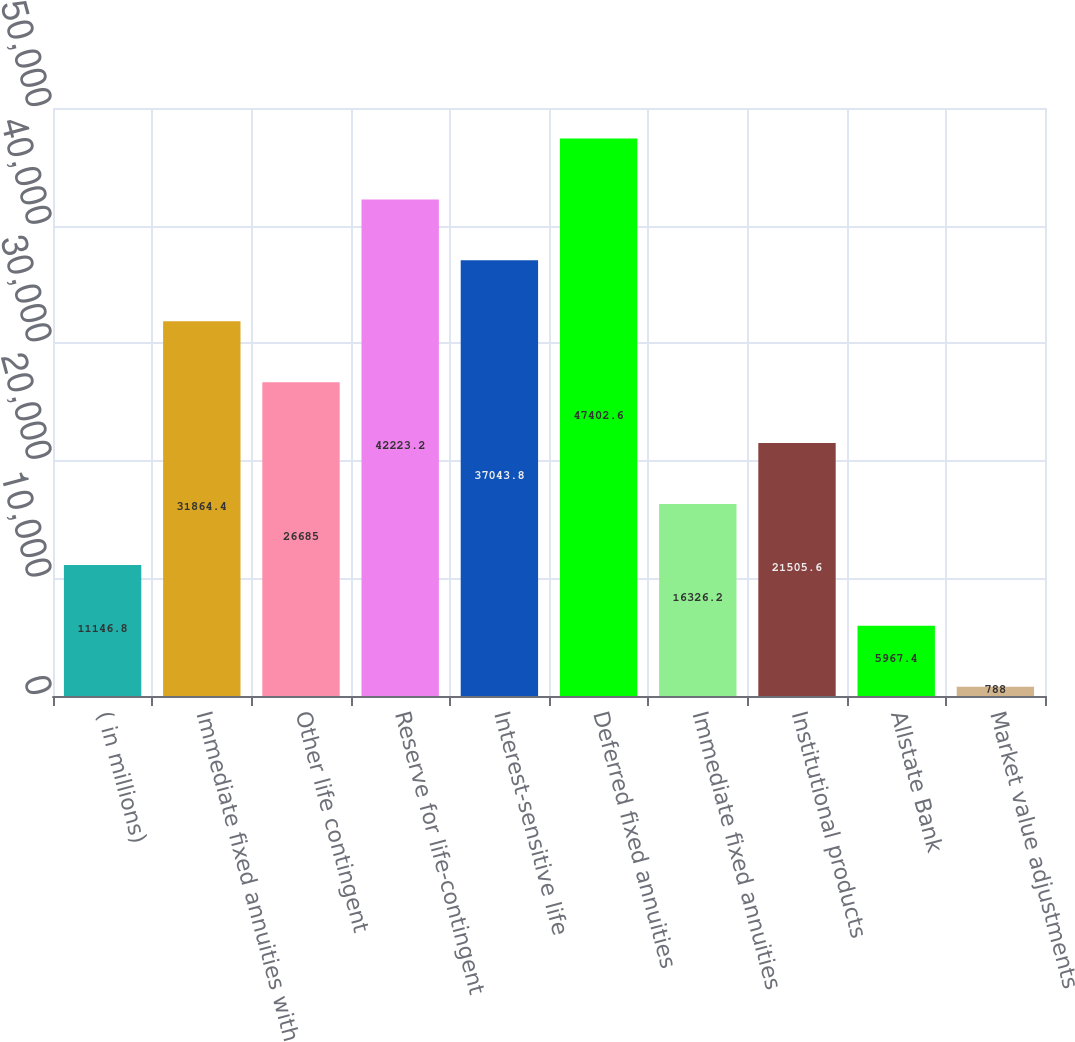<chart> <loc_0><loc_0><loc_500><loc_500><bar_chart><fcel>( in millions)<fcel>Immediate fixed annuities with<fcel>Other life contingent<fcel>Reserve for life-contingent<fcel>Interest-sensitive life<fcel>Deferred fixed annuities<fcel>Immediate fixed annuities<fcel>Institutional products<fcel>Allstate Bank<fcel>Market value adjustments<nl><fcel>11146.8<fcel>31864.4<fcel>26685<fcel>42223.2<fcel>37043.8<fcel>47402.6<fcel>16326.2<fcel>21505.6<fcel>5967.4<fcel>788<nl></chart> 